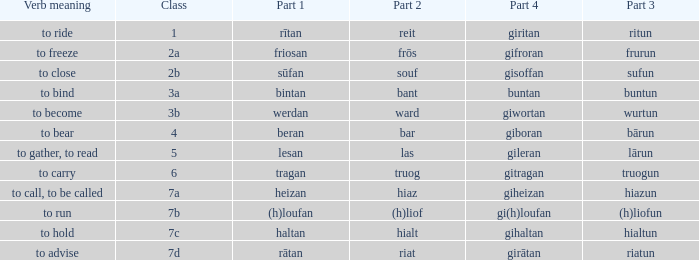What is the part 4 when part 1 is "lesan"? Gileran. 